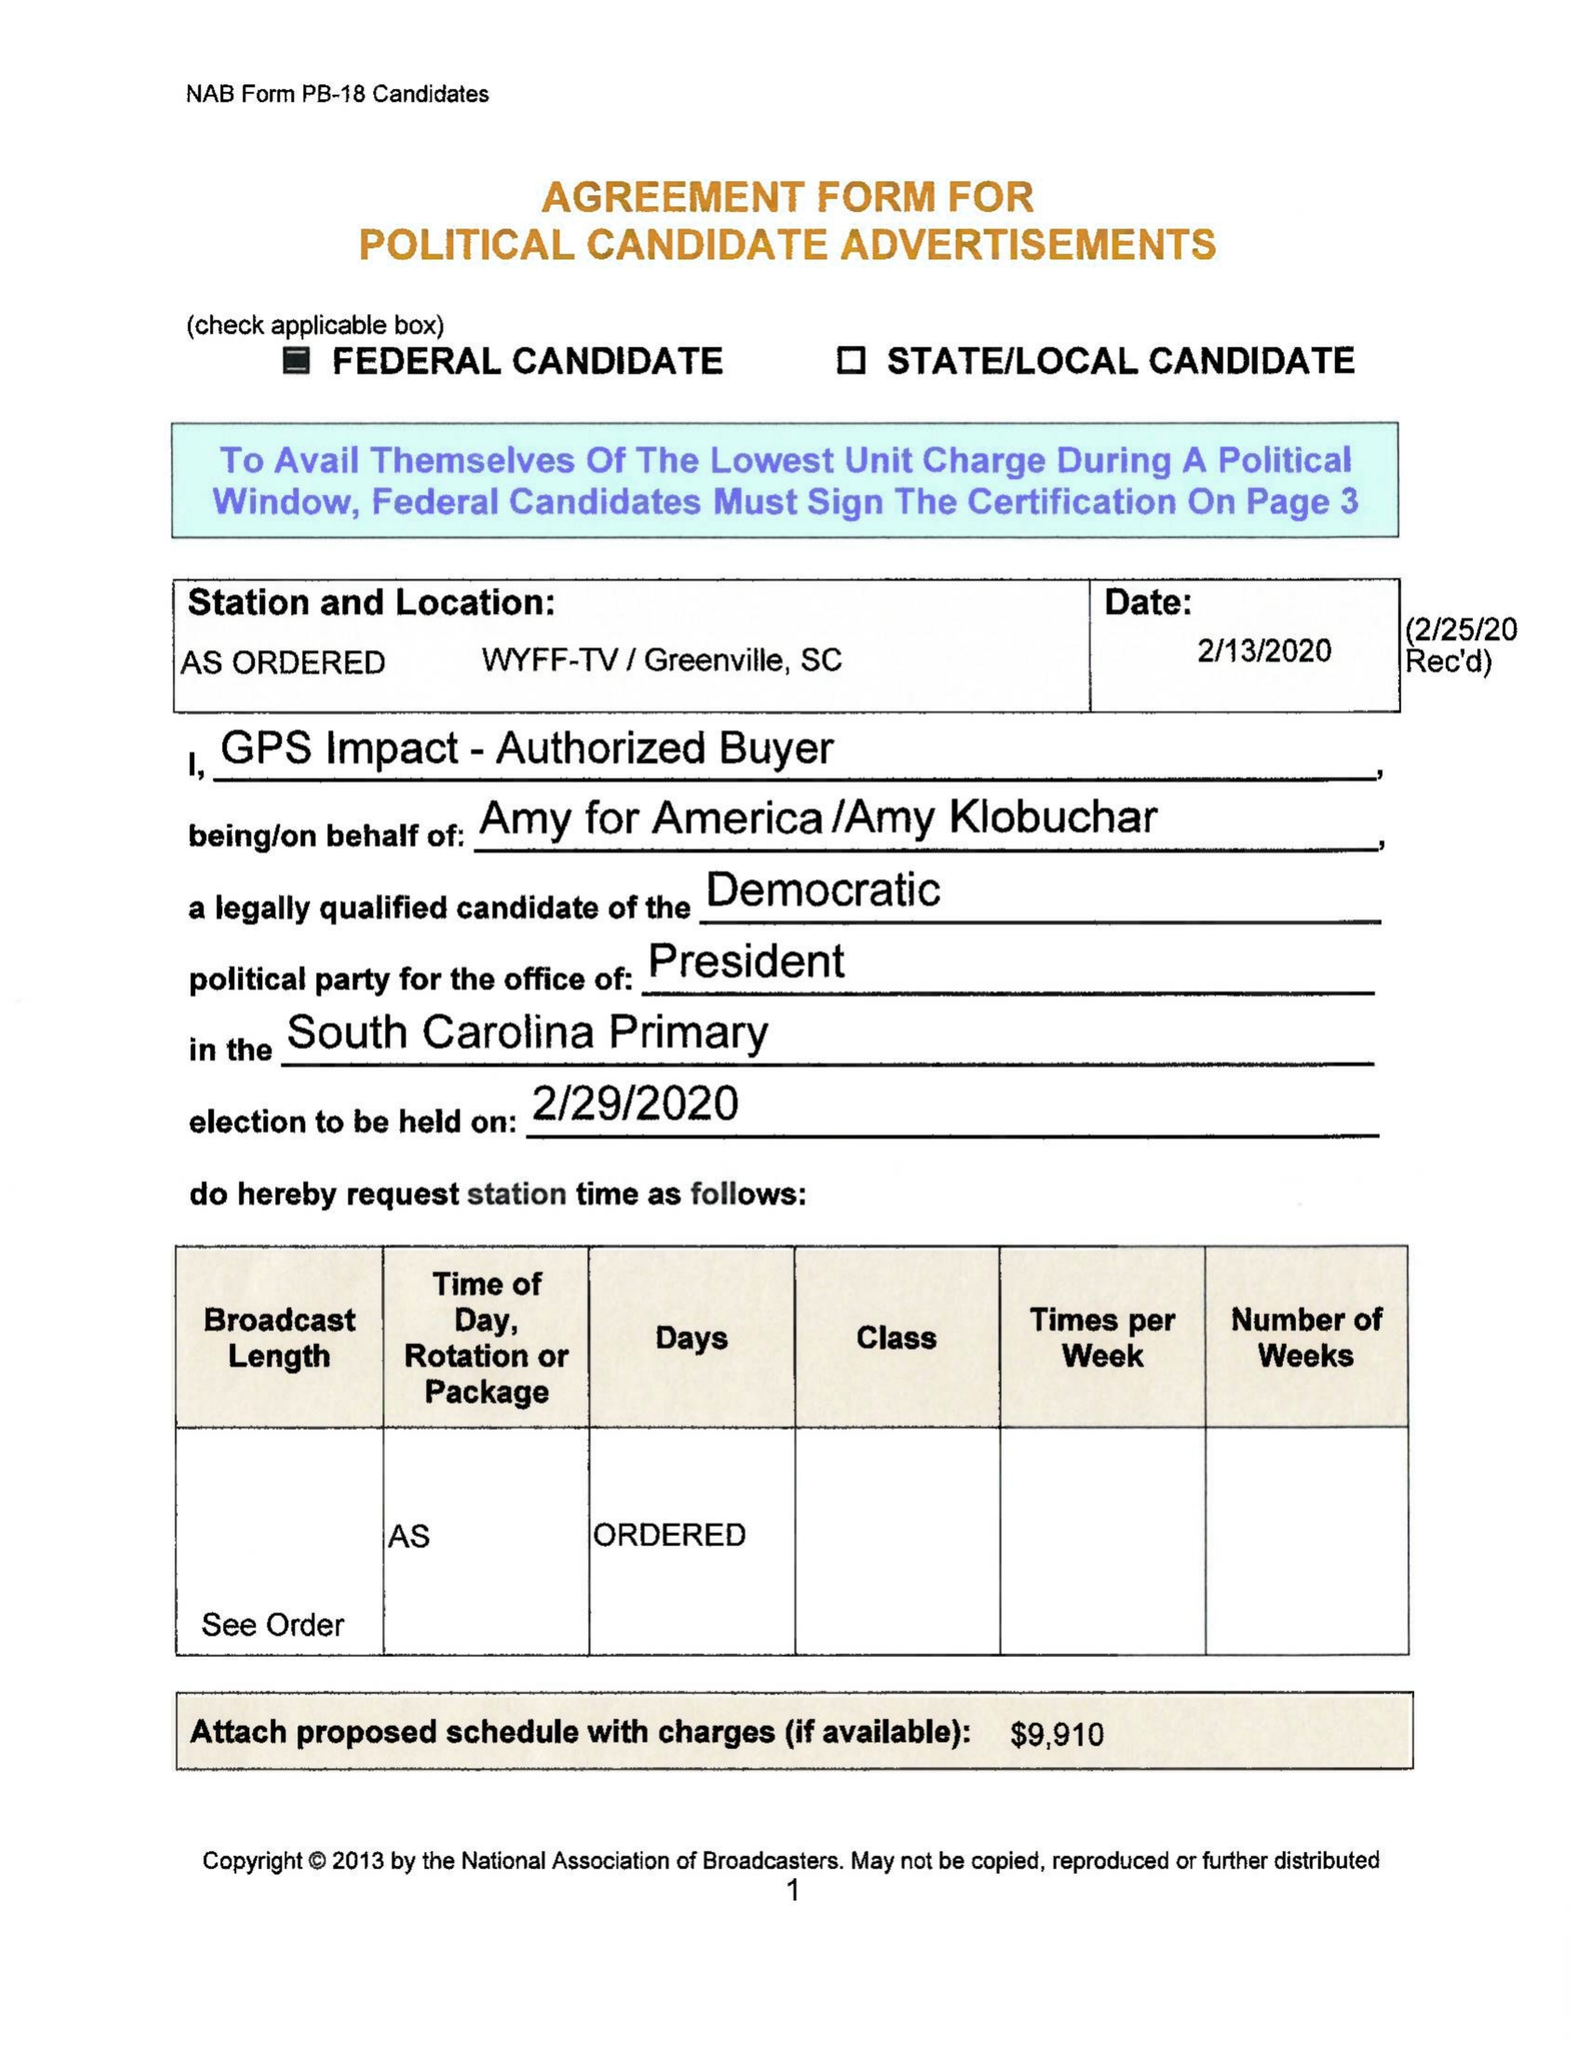What is the value for the advertiser?
Answer the question using a single word or phrase. AMY FOR AMERICA 